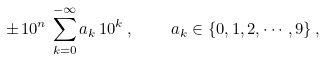<formula> <loc_0><loc_0><loc_500><loc_500>\pm \, 1 0 ^ { n } \, \sum _ { k = 0 } ^ { - \infty } a _ { k } \, 1 0 ^ { k } \, , \quad a _ { k } \in \{ 0 , 1 , 2 , \cdots , 9 \} \, ,</formula> 